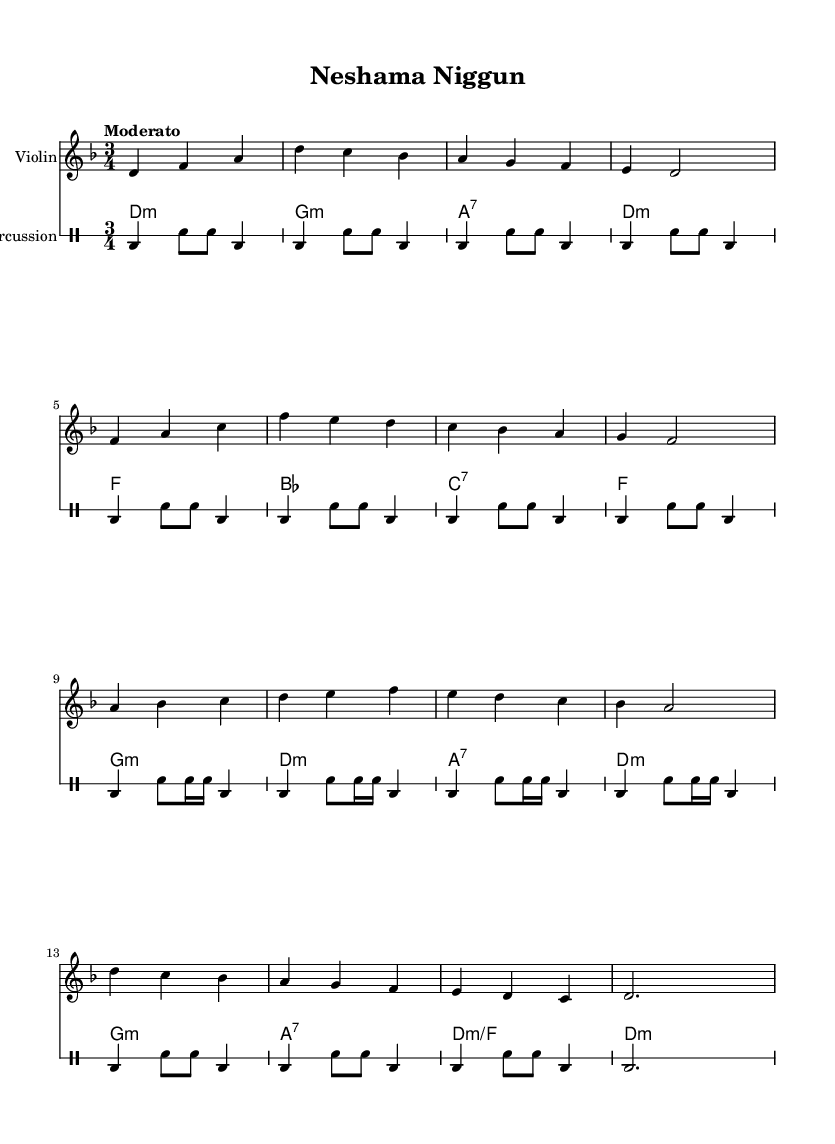What is the key signature of this music? The key signature is D minor, which typically includes one flat. This can be confirmed by looking at the key signature indicator at the beginning of the staff.
Answer: D minor What is the time signature of the piece? The time signature is 3/4, indicated at the start of the music. This means there are three beats in each measure, with a quarter note receiving one beat.
Answer: 3/4 What tempo is indicated for this piece? The tempo marking at the beginning is "Moderato," which indicates a moderate speed for performance. It suggests a tempo of approximately 108 to 120 beats per minute.
Answer: Moderato How many measures are in the violin part? By counting the measures in the violin line, there are a total of 16 measures. Each bar or measure is separated by vertical lines on the staff.
Answer: 16 What is the root chord in the first measure of the oud part? The root chord in the first measure is D minor, as indicated by "d4:m" at the beginning of the measure, where "d" represents the root note and "m" denotes that it is a minor chord.
Answer: D minor Which instrument is playing wordless melodies? The violin part is conveying wordless melodies, serving as the primary melodic instrument in Hasidic niggunim, which are typically expressive and free.
Answer: Violin What type of percussion pattern is used throughout the piece? The percussion pattern predominantly uses a bass drum and snare drum combination, creating a dance-like feel that supports the melodies, characterized by repeated rhythmic phrases.
Answer: Bass drum and snare drum 